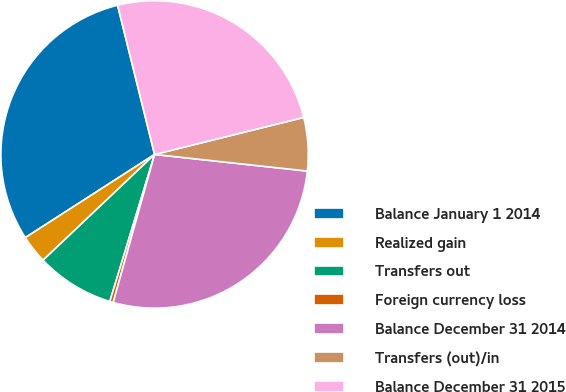Convert chart. <chart><loc_0><loc_0><loc_500><loc_500><pie_chart><fcel>Balance January 1 2014<fcel>Realized gain<fcel>Transfers out<fcel>Foreign currency loss<fcel>Balance December 31 2014<fcel>Transfers (out)/in<fcel>Balance December 31 2015<nl><fcel>30.24%<fcel>2.98%<fcel>8.22%<fcel>0.36%<fcel>27.62%<fcel>5.6%<fcel>25.0%<nl></chart> 